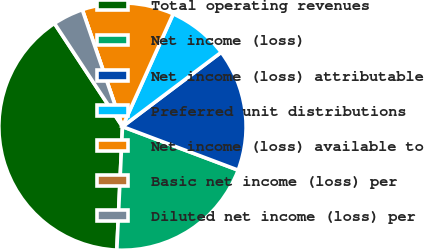Convert chart. <chart><loc_0><loc_0><loc_500><loc_500><pie_chart><fcel>Total operating revenues<fcel>Net income (loss)<fcel>Net income (loss) attributable<fcel>Preferred unit distributions<fcel>Net income (loss) available to<fcel>Basic net income (loss) per<fcel>Diluted net income (loss) per<nl><fcel>40.0%<fcel>20.0%<fcel>16.0%<fcel>8.0%<fcel>12.0%<fcel>0.0%<fcel>4.0%<nl></chart> 